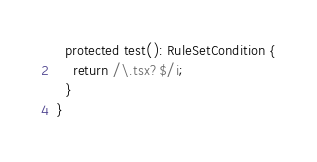<code> <loc_0><loc_0><loc_500><loc_500><_TypeScript_>  protected test(): RuleSetCondition {
    return /\.tsx?$/i;
  }
}
</code> 